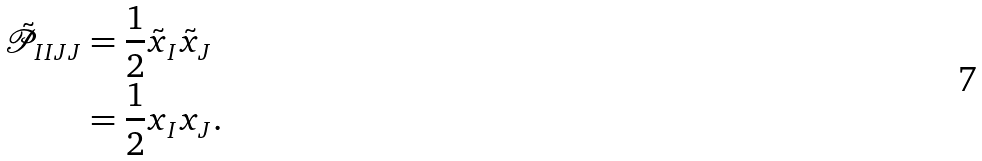<formula> <loc_0><loc_0><loc_500><loc_500>\tilde { \mathcal { P } } _ { I I J J } & = \frac { 1 } { 2 } \tilde { x } _ { I } \tilde { x } _ { J } \\ & = \frac { 1 } { 2 } x _ { I } x _ { J } .</formula> 